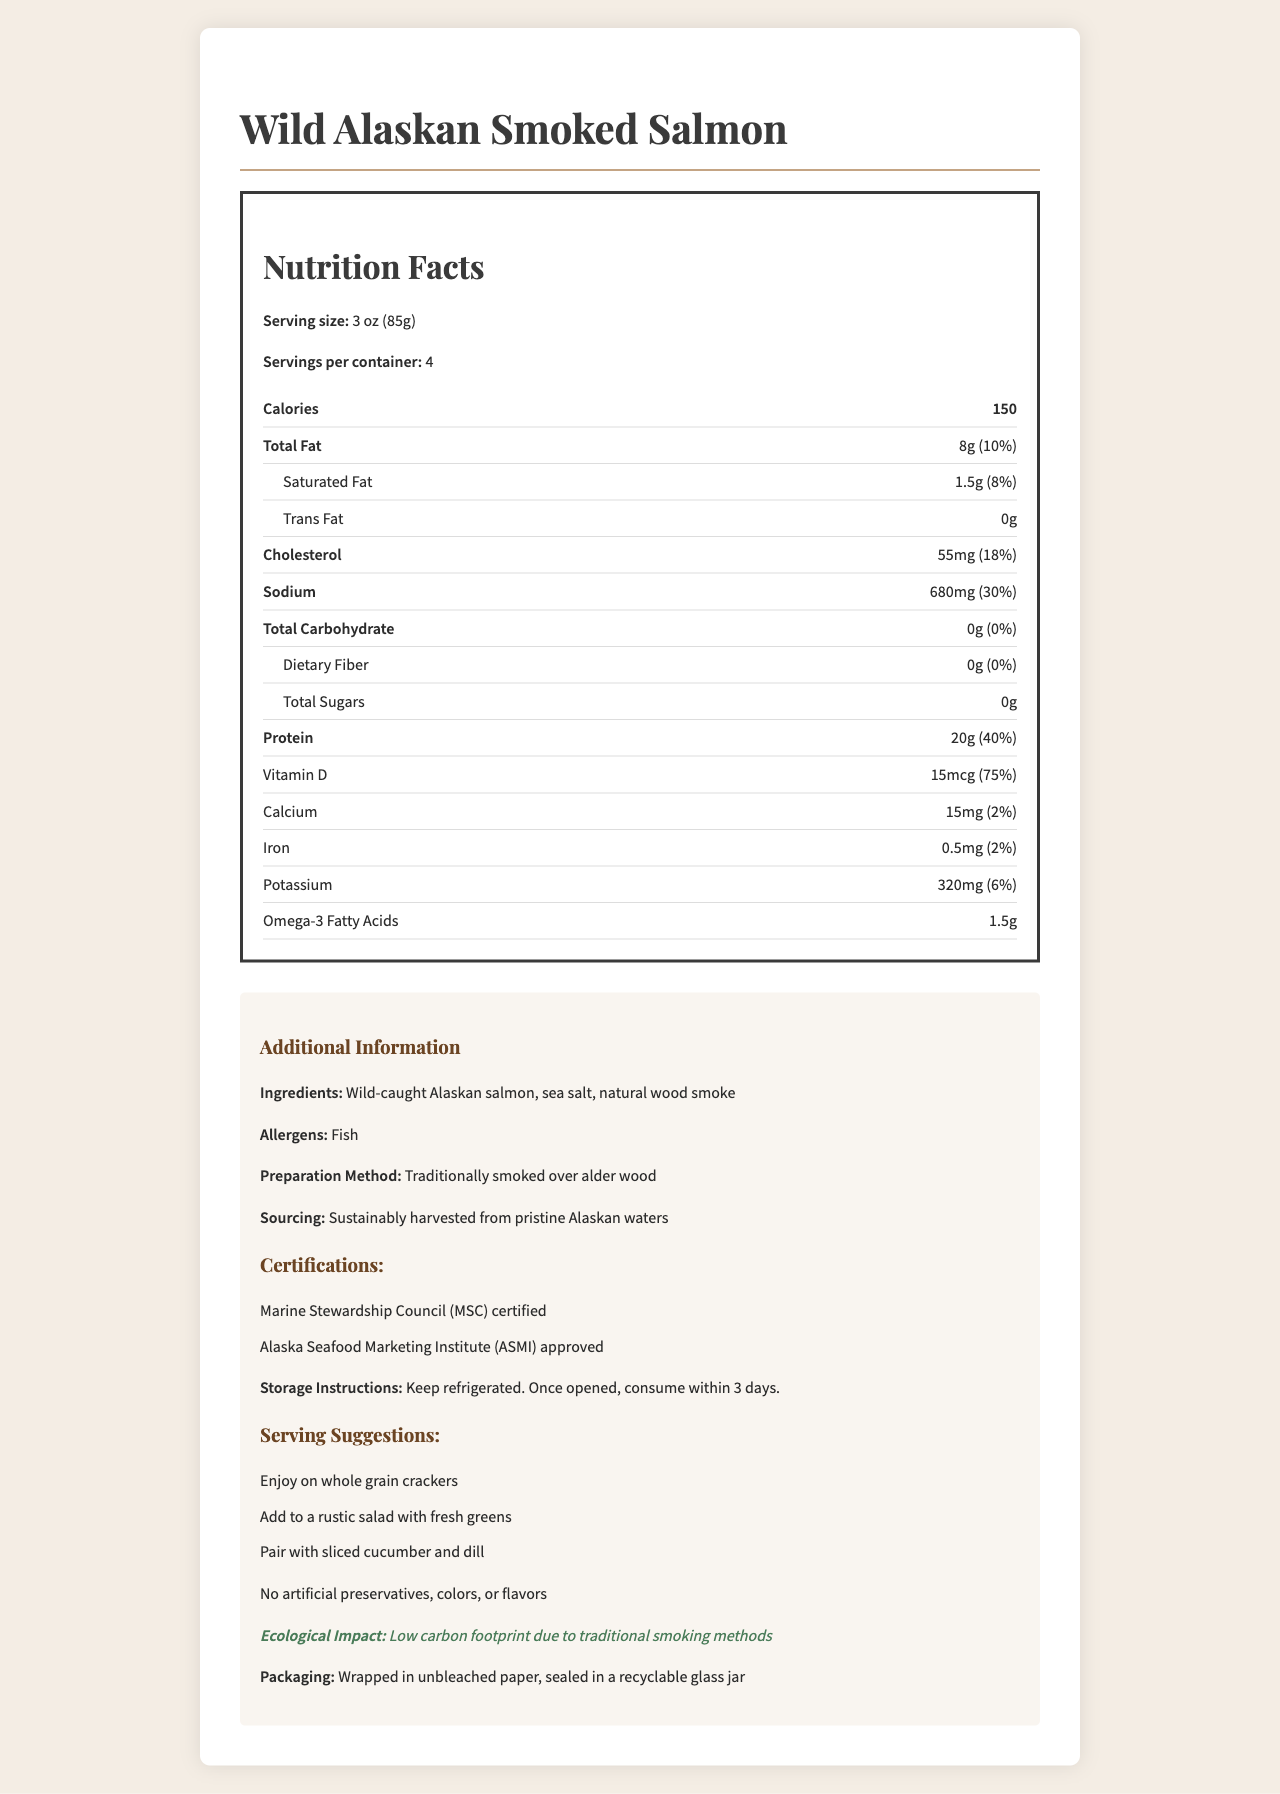who harvested the salmon? The document states, "Sustainably harvested from pristine Alaskan waters" in the sourcing section.
Answer: Sustainably harvested from pristine Alaskan waters what are the allergens? The allergens listed in the document under the additional information section are "Fish".
Answer: Fish how many calories are in one serving of wild-caught smoked salmon? The nutrition facts state that each serving contains "150 calories".
Answer: 150 calories what is the amount of cholesterol per serving? The document states, "Cholesterol: 55mg" in the nutrition facts section.
Answer: 55mg what are the ingredients? The ingredients listed under the additional information section are "Wild-caught Alaskan salmon, sea salt, natural wood smoke".
Answer: Wild-caught Alaskan salmon, sea salt, natural wood smoke how much protein is in a serving of smoked salmon? The nutrition facts state that each serving contains "20g of protein".
Answer: 20g how should the smoked salmon be stored? The storage instructions in the document state, "Keep refrigerated. Once opened, consume within 3 days."
Answer: Keep refrigerated. Once opened, consume within 3 days. what certifications does the product have? A. USDA Organic B. Marine Stewardship Council (MSC) certified C. Fair Trade D. Alaska Seafood Marketing Institute (ASMI) approved The document states that the product is "Marine Stewardship Council (MSC) certified" and "Alaska Seafood Marketing Institute (ASMI) approved."
Answer: B and D which preparation method is used for the smoked salmon? A. Electric Smoking B. Alder Wood Smoking C. Gas Smoking The document states, "Traditionally smoked over alder wood" under the preparation method section.
Answer: B does the smoked salmon contain any added sugars? The nutrition facts indicate "Total Sugars: 0g," which means there are no added sugars.
Answer: No is the nutritional information for this product comprehensive? The document provides detailed nutrition facts, ingredients, allergens, preparation method, sourcing, certifications, storage instructions, serving suggestions, and additional information.
Answer: Yes summarize the main idea of the document. The document covers various aspects of the product, including its nutritional composition, ingredients, allergens, preparation method, sourcing, certifications, storage instructions, serving suggestions, and sustainable and ecological considerations.
Answer: The document provides detailed nutrition facts and additional information for Wild Alaskan Smoked Salmon, emphasizing its natural ingredients, traditional smoking preparation, sustainable sourcing, and certifications. who manufactures the smoked salmon? The document does not provide any information about the manufacturer.
Answer: Not enough information 